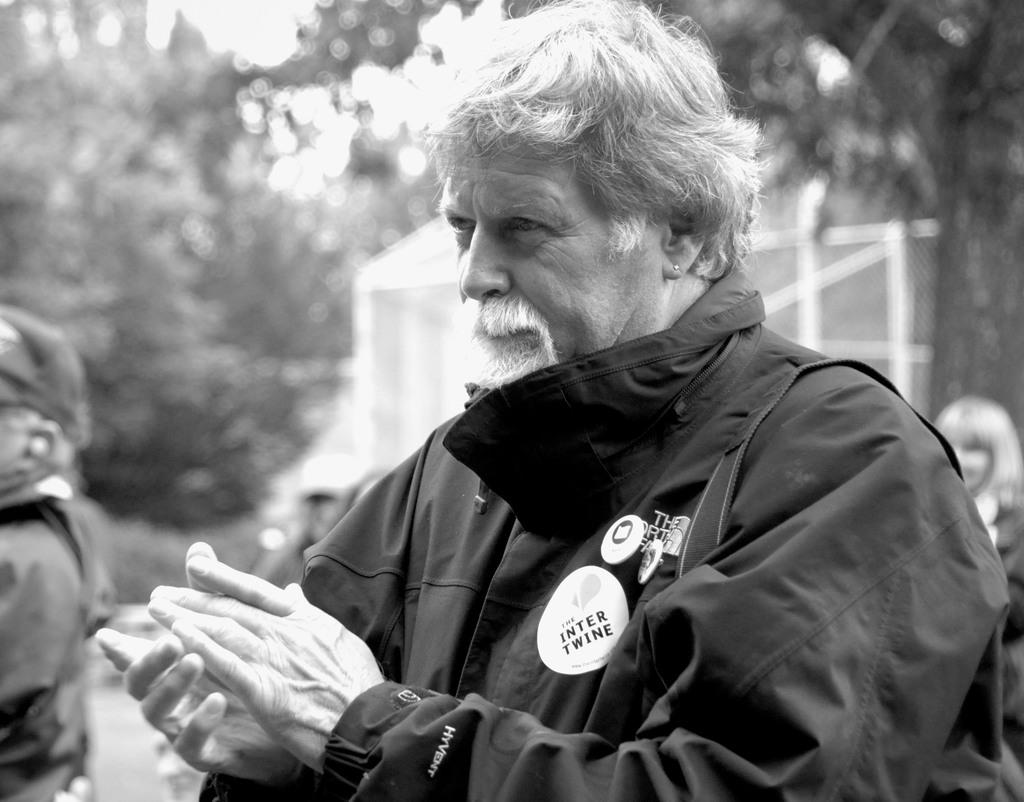Who is the main subject in the image? There is an old man in the image. What is the old man doing in the image? The old man is looking at someone and clapping. What type of riddle is the old man solving in the image? There is no riddle present in the image; the old man is simply looking at someone and clapping. 